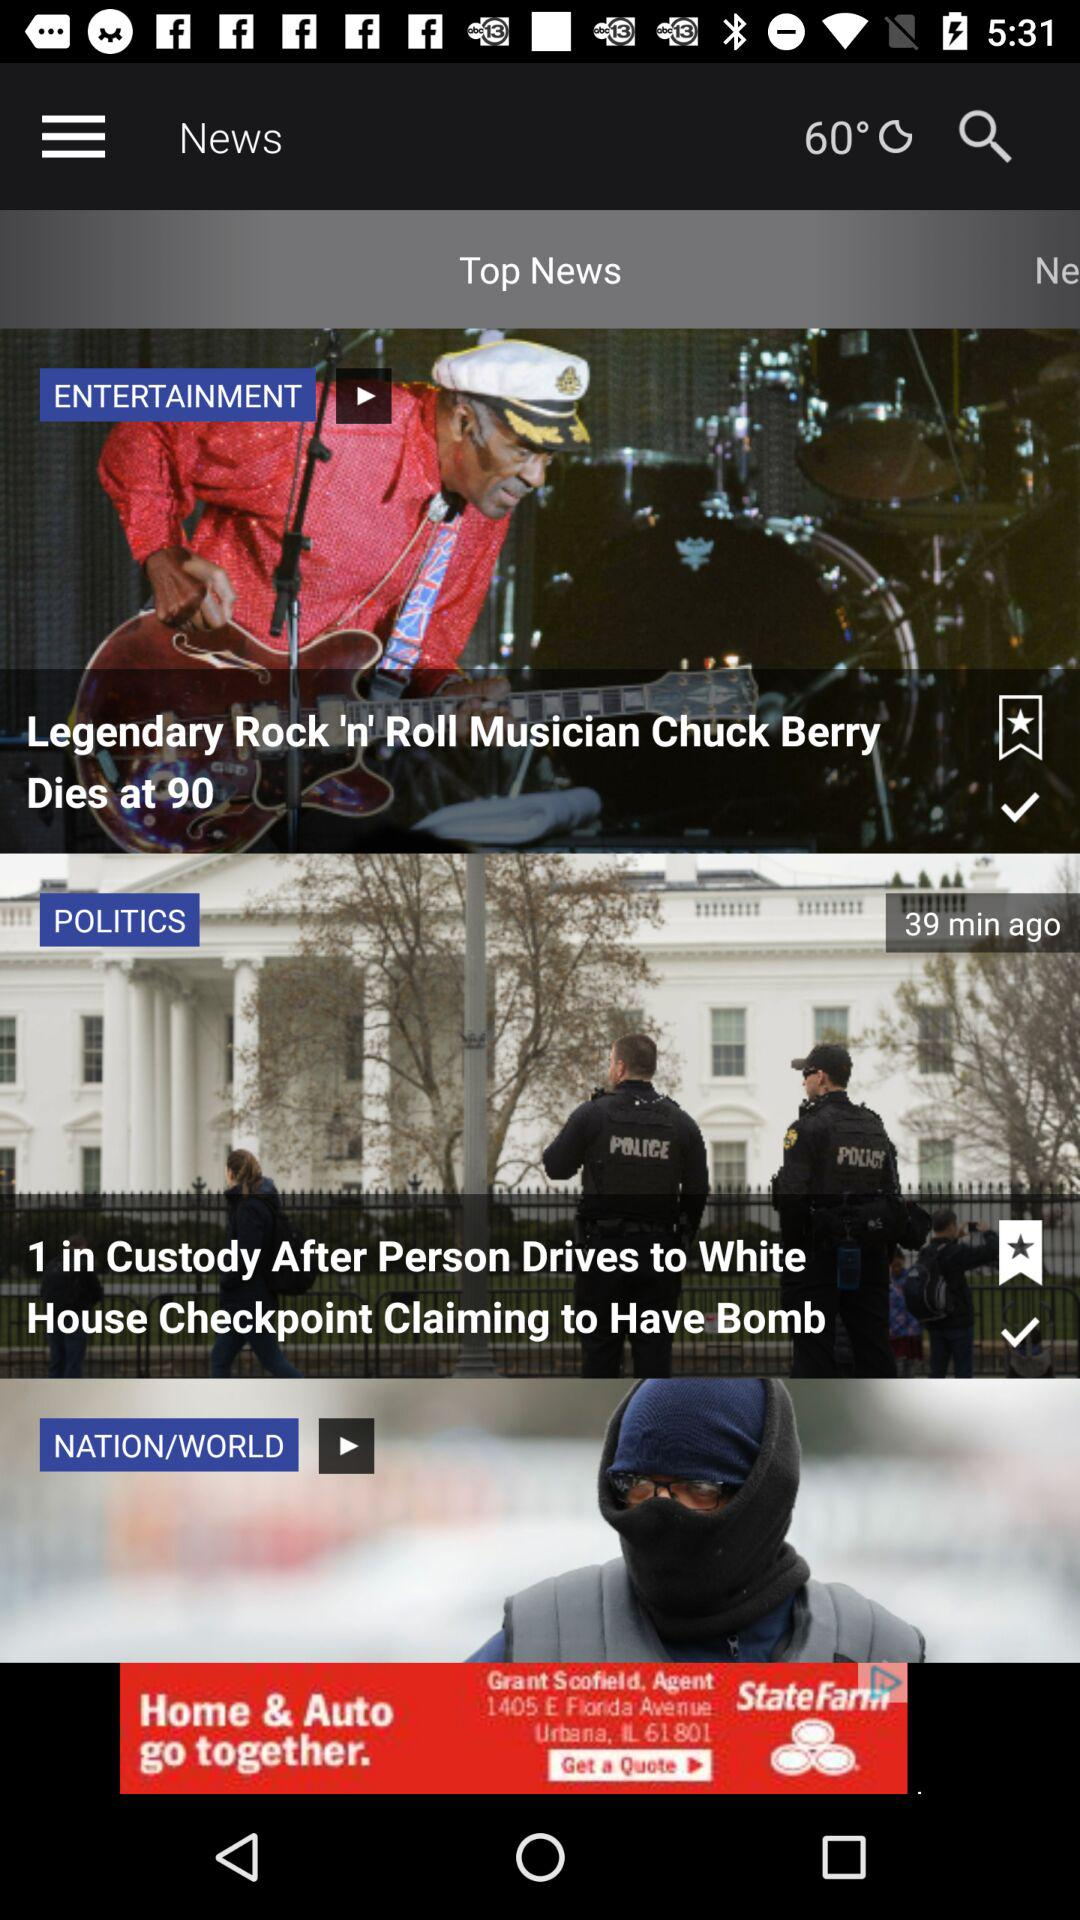What is the temperature? The temperature is 60°. 